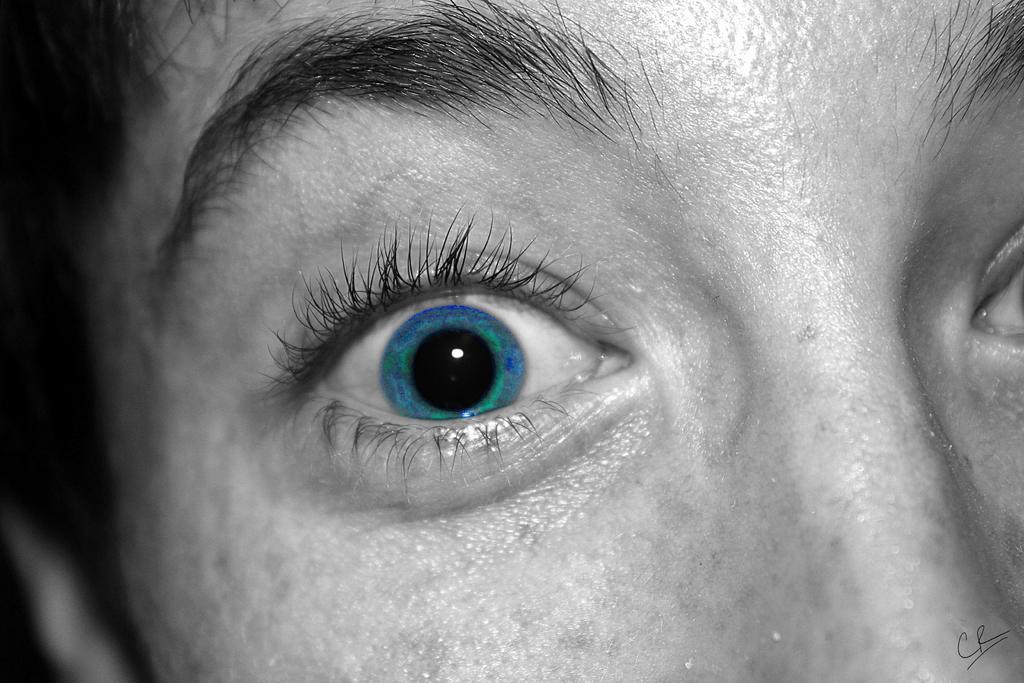Can you describe this image briefly? In this image there is a face of a person with nose, eyes and eyebrows. 